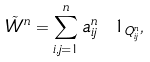<formula> <loc_0><loc_0><loc_500><loc_500>\tilde { W } ^ { n } = \sum _ { i , j = 1 } ^ { n } a ^ { n } _ { i j } \ 1 _ { Q ^ { n } _ { i j } } ,</formula> 